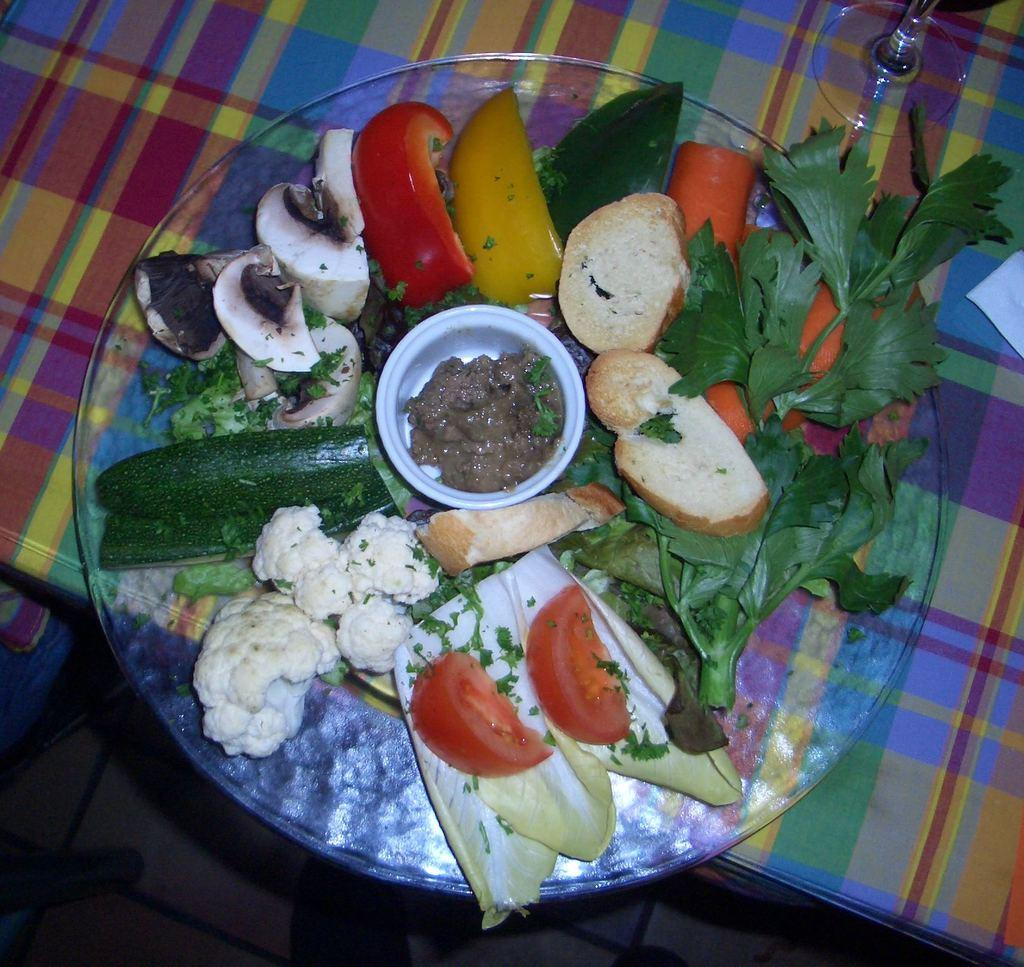What is in the center of the image on the table? There is a plate in the center of the image on a table. What vegetables are on the plate? The plate contains tomatoes, cucumbers, and cabbage. Are there any other items on the plate? Yes, there are other items on the plate. What can be seen on the table besides the plate? There is a glass and a tissue on the table. Are there any dinosaurs or jellyfish visible in the image? No, there are no dinosaurs or jellyfish present in the image. Is there a throne in the image? No, there is no throne present in the image. 